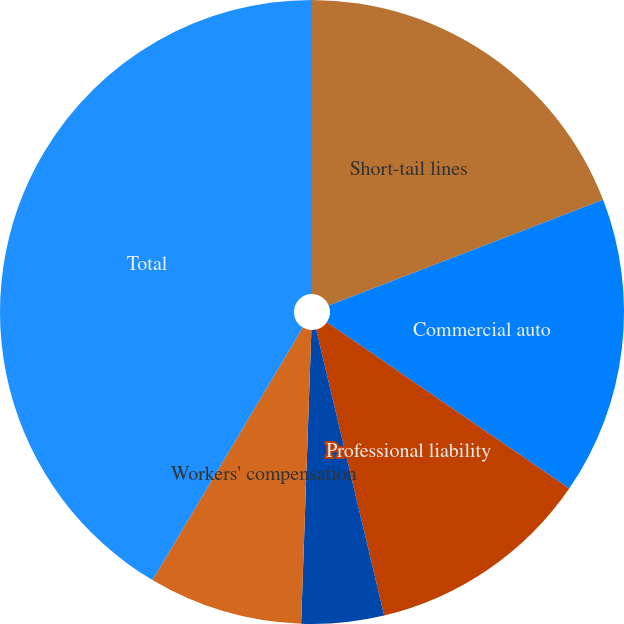<chart> <loc_0><loc_0><loc_500><loc_500><pie_chart><fcel>Short-tail lines<fcel>Commercial auto<fcel>Professional liability<fcel>Other liability<fcel>Workers' compensation<fcel>Total<nl><fcel>19.15%<fcel>15.43%<fcel>11.71%<fcel>4.27%<fcel>7.99%<fcel>41.46%<nl></chart> 